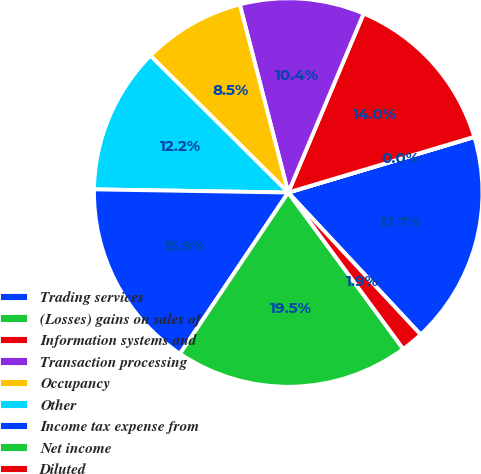Convert chart to OTSL. <chart><loc_0><loc_0><loc_500><loc_500><pie_chart><fcel>Trading services<fcel>(Losses) gains on sales of<fcel>Information systems and<fcel>Transaction processing<fcel>Occupancy<fcel>Other<fcel>Income tax expense from<fcel>Net income<fcel>Diluted<nl><fcel>17.67%<fcel>0.02%<fcel>14.02%<fcel>10.36%<fcel>8.54%<fcel>12.19%<fcel>15.85%<fcel>19.5%<fcel>1.85%<nl></chart> 